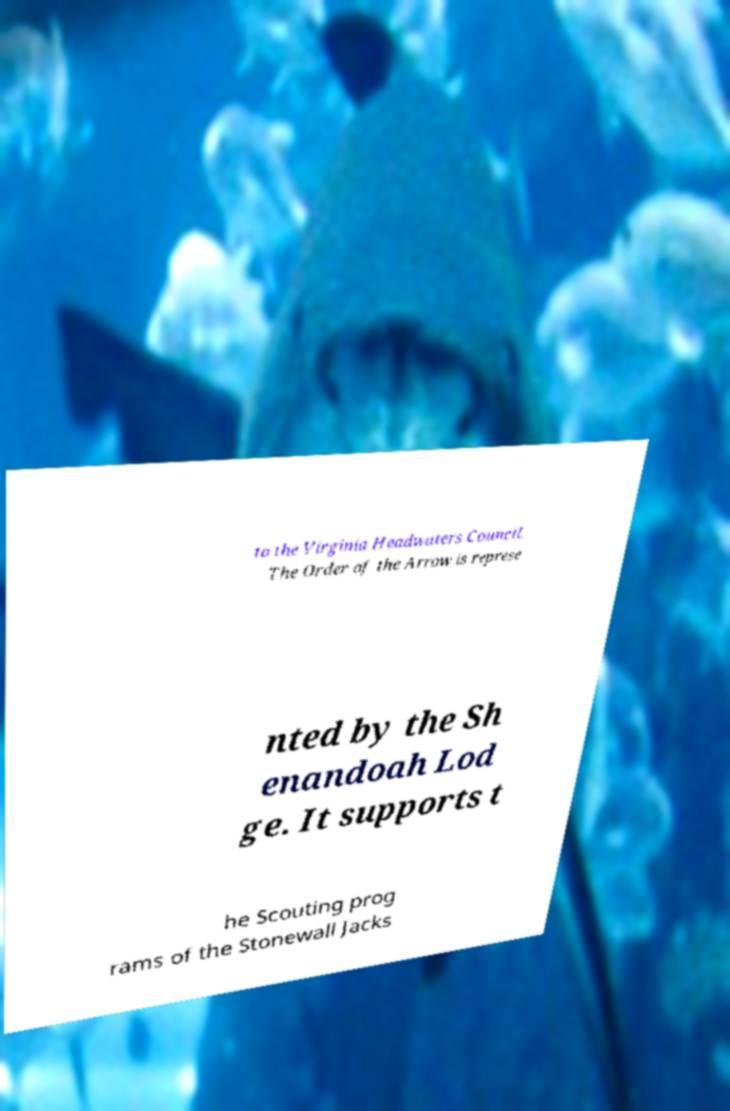Please read and relay the text visible in this image. What does it say? to the Virginia Headwaters Council. The Order of the Arrow is represe nted by the Sh enandoah Lod ge. It supports t he Scouting prog rams of the Stonewall Jacks 